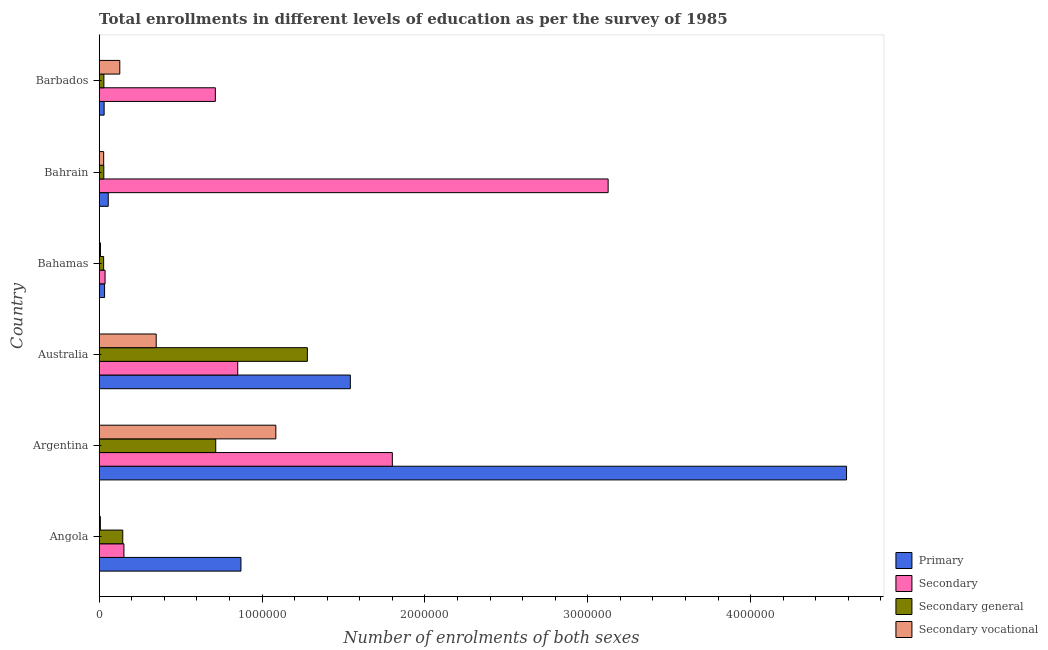How many different coloured bars are there?
Provide a short and direct response. 4. How many bars are there on the 4th tick from the top?
Keep it short and to the point. 4. In how many cases, is the number of bars for a given country not equal to the number of legend labels?
Provide a succinct answer. 0. What is the number of enrolments in secondary general education in Angola?
Your response must be concise. 1.45e+05. Across all countries, what is the maximum number of enrolments in secondary vocational education?
Offer a terse response. 1.08e+06. Across all countries, what is the minimum number of enrolments in primary education?
Ensure brevity in your answer.  3.02e+04. In which country was the number of enrolments in secondary vocational education minimum?
Provide a succinct answer. Angola. What is the total number of enrolments in secondary education in the graph?
Offer a very short reply. 6.68e+06. What is the difference between the number of enrolments in primary education in Angola and that in Bahrain?
Provide a short and direct response. 8.15e+05. What is the difference between the number of enrolments in secondary general education in Australia and the number of enrolments in secondary education in Bahamas?
Ensure brevity in your answer.  1.24e+06. What is the average number of enrolments in primary education per country?
Ensure brevity in your answer.  1.19e+06. What is the difference between the number of enrolments in secondary vocational education and number of enrolments in secondary general education in Angola?
Your answer should be very brief. -1.37e+05. What is the ratio of the number of enrolments in secondary vocational education in Bahamas to that in Barbados?
Your answer should be very brief. 0.06. What is the difference between the highest and the second highest number of enrolments in secondary vocational education?
Your answer should be very brief. 7.35e+05. What is the difference between the highest and the lowest number of enrolments in secondary vocational education?
Offer a very short reply. 1.08e+06. In how many countries, is the number of enrolments in secondary general education greater than the average number of enrolments in secondary general education taken over all countries?
Make the answer very short. 2. Is it the case that in every country, the sum of the number of enrolments in secondary education and number of enrolments in primary education is greater than the sum of number of enrolments in secondary general education and number of enrolments in secondary vocational education?
Your response must be concise. No. What does the 2nd bar from the top in Bahrain represents?
Your answer should be very brief. Secondary general. What does the 4th bar from the bottom in Angola represents?
Make the answer very short. Secondary vocational. How many countries are there in the graph?
Your response must be concise. 6. Are the values on the major ticks of X-axis written in scientific E-notation?
Give a very brief answer. No. Does the graph contain grids?
Ensure brevity in your answer.  No. Where does the legend appear in the graph?
Offer a very short reply. Bottom right. How many legend labels are there?
Your response must be concise. 4. How are the legend labels stacked?
Offer a terse response. Vertical. What is the title of the graph?
Keep it short and to the point. Total enrollments in different levels of education as per the survey of 1985. Does "Offering training" appear as one of the legend labels in the graph?
Give a very brief answer. No. What is the label or title of the X-axis?
Your response must be concise. Number of enrolments of both sexes. What is the Number of enrolments of both sexes of Primary in Angola?
Give a very brief answer. 8.70e+05. What is the Number of enrolments of both sexes of Secondary in Angola?
Your response must be concise. 1.52e+05. What is the Number of enrolments of both sexes in Secondary general in Angola?
Ensure brevity in your answer.  1.45e+05. What is the Number of enrolments of both sexes in Secondary vocational in Angola?
Offer a very short reply. 7147. What is the Number of enrolments of both sexes in Primary in Argentina?
Make the answer very short. 4.59e+06. What is the Number of enrolments of both sexes in Secondary in Argentina?
Your response must be concise. 1.80e+06. What is the Number of enrolments of both sexes of Secondary general in Argentina?
Your answer should be very brief. 7.16e+05. What is the Number of enrolments of both sexes in Secondary vocational in Argentina?
Provide a succinct answer. 1.08e+06. What is the Number of enrolments of both sexes of Primary in Australia?
Your answer should be compact. 1.54e+06. What is the Number of enrolments of both sexes of Secondary in Australia?
Ensure brevity in your answer.  8.51e+05. What is the Number of enrolments of both sexes in Secondary general in Australia?
Offer a terse response. 1.28e+06. What is the Number of enrolments of both sexes in Secondary vocational in Australia?
Your answer should be compact. 3.50e+05. What is the Number of enrolments of both sexes of Primary in Bahamas?
Provide a short and direct response. 3.29e+04. What is the Number of enrolments of both sexes of Secondary in Bahamas?
Your answer should be very brief. 3.59e+04. What is the Number of enrolments of both sexes of Secondary general in Bahamas?
Provide a short and direct response. 2.71e+04. What is the Number of enrolments of both sexes in Secondary vocational in Bahamas?
Ensure brevity in your answer.  7648. What is the Number of enrolments of both sexes in Primary in Bahrain?
Give a very brief answer. 5.55e+04. What is the Number of enrolments of both sexes of Secondary in Bahrain?
Your response must be concise. 3.13e+06. What is the Number of enrolments of both sexes in Secondary general in Bahrain?
Make the answer very short. 2.83e+04. What is the Number of enrolments of both sexes in Secondary vocational in Bahrain?
Give a very brief answer. 2.73e+04. What is the Number of enrolments of both sexes in Primary in Barbados?
Keep it short and to the point. 3.02e+04. What is the Number of enrolments of both sexes in Secondary in Barbados?
Your response must be concise. 7.13e+05. What is the Number of enrolments of both sexes in Secondary general in Barbados?
Ensure brevity in your answer.  2.87e+04. What is the Number of enrolments of both sexes in Secondary vocational in Barbados?
Keep it short and to the point. 1.26e+05. Across all countries, what is the maximum Number of enrolments of both sexes in Primary?
Offer a terse response. 4.59e+06. Across all countries, what is the maximum Number of enrolments of both sexes of Secondary?
Provide a short and direct response. 3.13e+06. Across all countries, what is the maximum Number of enrolments of both sexes of Secondary general?
Provide a succinct answer. 1.28e+06. Across all countries, what is the maximum Number of enrolments of both sexes in Secondary vocational?
Your answer should be compact. 1.08e+06. Across all countries, what is the minimum Number of enrolments of both sexes of Primary?
Offer a terse response. 3.02e+04. Across all countries, what is the minimum Number of enrolments of both sexes in Secondary?
Provide a short and direct response. 3.59e+04. Across all countries, what is the minimum Number of enrolments of both sexes in Secondary general?
Offer a very short reply. 2.71e+04. Across all countries, what is the minimum Number of enrolments of both sexes in Secondary vocational?
Your answer should be compact. 7147. What is the total Number of enrolments of both sexes of Primary in the graph?
Your response must be concise. 7.12e+06. What is the total Number of enrolments of both sexes in Secondary in the graph?
Provide a succinct answer. 6.68e+06. What is the total Number of enrolments of both sexes in Secondary general in the graph?
Offer a very short reply. 2.22e+06. What is the total Number of enrolments of both sexes of Secondary vocational in the graph?
Your answer should be very brief. 1.60e+06. What is the difference between the Number of enrolments of both sexes of Primary in Angola and that in Argentina?
Provide a succinct answer. -3.72e+06. What is the difference between the Number of enrolments of both sexes in Secondary in Angola and that in Argentina?
Your answer should be very brief. -1.65e+06. What is the difference between the Number of enrolments of both sexes in Secondary general in Angola and that in Argentina?
Your response must be concise. -5.71e+05. What is the difference between the Number of enrolments of both sexes of Secondary vocational in Angola and that in Argentina?
Ensure brevity in your answer.  -1.08e+06. What is the difference between the Number of enrolments of both sexes of Primary in Angola and that in Australia?
Provide a short and direct response. -6.72e+05. What is the difference between the Number of enrolments of both sexes of Secondary in Angola and that in Australia?
Ensure brevity in your answer.  -6.99e+05. What is the difference between the Number of enrolments of both sexes of Secondary general in Angola and that in Australia?
Keep it short and to the point. -1.13e+06. What is the difference between the Number of enrolments of both sexes of Secondary vocational in Angola and that in Australia?
Your response must be concise. -3.43e+05. What is the difference between the Number of enrolments of both sexes of Primary in Angola and that in Bahamas?
Provide a short and direct response. 8.37e+05. What is the difference between the Number of enrolments of both sexes of Secondary in Angola and that in Bahamas?
Ensure brevity in your answer.  1.16e+05. What is the difference between the Number of enrolments of both sexes of Secondary general in Angola and that in Bahamas?
Offer a very short reply. 1.17e+05. What is the difference between the Number of enrolments of both sexes of Secondary vocational in Angola and that in Bahamas?
Provide a short and direct response. -501. What is the difference between the Number of enrolments of both sexes of Primary in Angola and that in Bahrain?
Provide a short and direct response. 8.15e+05. What is the difference between the Number of enrolments of both sexes in Secondary in Angola and that in Bahrain?
Provide a short and direct response. -2.97e+06. What is the difference between the Number of enrolments of both sexes in Secondary general in Angola and that in Bahrain?
Give a very brief answer. 1.16e+05. What is the difference between the Number of enrolments of both sexes of Secondary vocational in Angola and that in Bahrain?
Make the answer very short. -2.02e+04. What is the difference between the Number of enrolments of both sexes in Primary in Angola and that in Barbados?
Offer a terse response. 8.40e+05. What is the difference between the Number of enrolments of both sexes in Secondary in Angola and that in Barbados?
Keep it short and to the point. -5.61e+05. What is the difference between the Number of enrolments of both sexes of Secondary general in Angola and that in Barbados?
Provide a short and direct response. 1.16e+05. What is the difference between the Number of enrolments of both sexes in Secondary vocational in Angola and that in Barbados?
Keep it short and to the point. -1.19e+05. What is the difference between the Number of enrolments of both sexes in Primary in Argentina and that in Australia?
Offer a terse response. 3.05e+06. What is the difference between the Number of enrolments of both sexes in Secondary in Argentina and that in Australia?
Offer a very short reply. 9.49e+05. What is the difference between the Number of enrolments of both sexes in Secondary general in Argentina and that in Australia?
Your response must be concise. -5.63e+05. What is the difference between the Number of enrolments of both sexes in Secondary vocational in Argentina and that in Australia?
Offer a very short reply. 7.35e+05. What is the difference between the Number of enrolments of both sexes of Primary in Argentina and that in Bahamas?
Provide a short and direct response. 4.56e+06. What is the difference between the Number of enrolments of both sexes of Secondary in Argentina and that in Bahamas?
Your answer should be compact. 1.76e+06. What is the difference between the Number of enrolments of both sexes in Secondary general in Argentina and that in Bahamas?
Provide a succinct answer. 6.88e+05. What is the difference between the Number of enrolments of both sexes of Secondary vocational in Argentina and that in Bahamas?
Provide a succinct answer. 1.08e+06. What is the difference between the Number of enrolments of both sexes of Primary in Argentina and that in Bahrain?
Provide a short and direct response. 4.53e+06. What is the difference between the Number of enrolments of both sexes in Secondary in Argentina and that in Bahrain?
Offer a very short reply. -1.33e+06. What is the difference between the Number of enrolments of both sexes of Secondary general in Argentina and that in Bahrain?
Give a very brief answer. 6.87e+05. What is the difference between the Number of enrolments of both sexes of Secondary vocational in Argentina and that in Bahrain?
Give a very brief answer. 1.06e+06. What is the difference between the Number of enrolments of both sexes of Primary in Argentina and that in Barbados?
Provide a succinct answer. 4.56e+06. What is the difference between the Number of enrolments of both sexes in Secondary in Argentina and that in Barbados?
Give a very brief answer. 1.09e+06. What is the difference between the Number of enrolments of both sexes in Secondary general in Argentina and that in Barbados?
Keep it short and to the point. 6.87e+05. What is the difference between the Number of enrolments of both sexes of Secondary vocational in Argentina and that in Barbados?
Your answer should be very brief. 9.58e+05. What is the difference between the Number of enrolments of both sexes in Primary in Australia and that in Bahamas?
Provide a succinct answer. 1.51e+06. What is the difference between the Number of enrolments of both sexes in Secondary in Australia and that in Bahamas?
Your response must be concise. 8.15e+05. What is the difference between the Number of enrolments of both sexes in Secondary general in Australia and that in Bahamas?
Offer a very short reply. 1.25e+06. What is the difference between the Number of enrolments of both sexes in Secondary vocational in Australia and that in Bahamas?
Your answer should be very brief. 3.42e+05. What is the difference between the Number of enrolments of both sexes in Primary in Australia and that in Bahrain?
Provide a succinct answer. 1.49e+06. What is the difference between the Number of enrolments of both sexes of Secondary in Australia and that in Bahrain?
Your answer should be very brief. -2.27e+06. What is the difference between the Number of enrolments of both sexes in Secondary general in Australia and that in Bahrain?
Offer a terse response. 1.25e+06. What is the difference between the Number of enrolments of both sexes of Secondary vocational in Australia and that in Bahrain?
Keep it short and to the point. 3.23e+05. What is the difference between the Number of enrolments of both sexes of Primary in Australia and that in Barbados?
Your answer should be compact. 1.51e+06. What is the difference between the Number of enrolments of both sexes of Secondary in Australia and that in Barbados?
Give a very brief answer. 1.38e+05. What is the difference between the Number of enrolments of both sexes in Secondary general in Australia and that in Barbados?
Offer a terse response. 1.25e+06. What is the difference between the Number of enrolments of both sexes in Secondary vocational in Australia and that in Barbados?
Offer a terse response. 2.24e+05. What is the difference between the Number of enrolments of both sexes of Primary in Bahamas and that in Bahrain?
Give a very brief answer. -2.26e+04. What is the difference between the Number of enrolments of both sexes in Secondary in Bahamas and that in Bahrain?
Offer a very short reply. -3.09e+06. What is the difference between the Number of enrolments of both sexes of Secondary general in Bahamas and that in Bahrain?
Ensure brevity in your answer.  -1106. What is the difference between the Number of enrolments of both sexes of Secondary vocational in Bahamas and that in Bahrain?
Ensure brevity in your answer.  -1.97e+04. What is the difference between the Number of enrolments of both sexes in Primary in Bahamas and that in Barbados?
Your answer should be compact. 2753. What is the difference between the Number of enrolments of both sexes of Secondary in Bahamas and that in Barbados?
Your answer should be very brief. -6.77e+05. What is the difference between the Number of enrolments of both sexes of Secondary general in Bahamas and that in Barbados?
Keep it short and to the point. -1548. What is the difference between the Number of enrolments of both sexes of Secondary vocational in Bahamas and that in Barbados?
Your answer should be compact. -1.19e+05. What is the difference between the Number of enrolments of both sexes in Primary in Bahrain and that in Barbados?
Provide a short and direct response. 2.53e+04. What is the difference between the Number of enrolments of both sexes in Secondary in Bahrain and that in Barbados?
Provide a short and direct response. 2.41e+06. What is the difference between the Number of enrolments of both sexes in Secondary general in Bahrain and that in Barbados?
Provide a short and direct response. -442. What is the difference between the Number of enrolments of both sexes of Secondary vocational in Bahrain and that in Barbados?
Provide a short and direct response. -9.91e+04. What is the difference between the Number of enrolments of both sexes in Primary in Angola and the Number of enrolments of both sexes in Secondary in Argentina?
Give a very brief answer. -9.30e+05. What is the difference between the Number of enrolments of both sexes in Primary in Angola and the Number of enrolments of both sexes in Secondary general in Argentina?
Offer a very short reply. 1.55e+05. What is the difference between the Number of enrolments of both sexes of Primary in Angola and the Number of enrolments of both sexes of Secondary vocational in Argentina?
Make the answer very short. -2.14e+05. What is the difference between the Number of enrolments of both sexes of Secondary in Angola and the Number of enrolments of both sexes of Secondary general in Argentina?
Your response must be concise. -5.64e+05. What is the difference between the Number of enrolments of both sexes of Secondary in Angola and the Number of enrolments of both sexes of Secondary vocational in Argentina?
Keep it short and to the point. -9.33e+05. What is the difference between the Number of enrolments of both sexes of Secondary general in Angola and the Number of enrolments of both sexes of Secondary vocational in Argentina?
Provide a succinct answer. -9.40e+05. What is the difference between the Number of enrolments of both sexes in Primary in Angola and the Number of enrolments of both sexes in Secondary in Australia?
Offer a terse response. 1.98e+04. What is the difference between the Number of enrolments of both sexes in Primary in Angola and the Number of enrolments of both sexes in Secondary general in Australia?
Give a very brief answer. -4.08e+05. What is the difference between the Number of enrolments of both sexes in Primary in Angola and the Number of enrolments of both sexes in Secondary vocational in Australia?
Your answer should be compact. 5.20e+05. What is the difference between the Number of enrolments of both sexes in Secondary in Angola and the Number of enrolments of both sexes in Secondary general in Australia?
Ensure brevity in your answer.  -1.13e+06. What is the difference between the Number of enrolments of both sexes in Secondary in Angola and the Number of enrolments of both sexes in Secondary vocational in Australia?
Provide a succinct answer. -1.98e+05. What is the difference between the Number of enrolments of both sexes of Secondary general in Angola and the Number of enrolments of both sexes of Secondary vocational in Australia?
Keep it short and to the point. -2.05e+05. What is the difference between the Number of enrolments of both sexes of Primary in Angola and the Number of enrolments of both sexes of Secondary in Bahamas?
Your answer should be very brief. 8.35e+05. What is the difference between the Number of enrolments of both sexes of Primary in Angola and the Number of enrolments of both sexes of Secondary general in Bahamas?
Your response must be concise. 8.43e+05. What is the difference between the Number of enrolments of both sexes of Primary in Angola and the Number of enrolments of both sexes of Secondary vocational in Bahamas?
Your answer should be compact. 8.63e+05. What is the difference between the Number of enrolments of both sexes of Secondary in Angola and the Number of enrolments of both sexes of Secondary general in Bahamas?
Provide a succinct answer. 1.25e+05. What is the difference between the Number of enrolments of both sexes in Secondary in Angola and the Number of enrolments of both sexes in Secondary vocational in Bahamas?
Offer a terse response. 1.44e+05. What is the difference between the Number of enrolments of both sexes of Secondary general in Angola and the Number of enrolments of both sexes of Secondary vocational in Bahamas?
Make the answer very short. 1.37e+05. What is the difference between the Number of enrolments of both sexes in Primary in Angola and the Number of enrolments of both sexes in Secondary in Bahrain?
Your response must be concise. -2.25e+06. What is the difference between the Number of enrolments of both sexes in Primary in Angola and the Number of enrolments of both sexes in Secondary general in Bahrain?
Offer a very short reply. 8.42e+05. What is the difference between the Number of enrolments of both sexes in Primary in Angola and the Number of enrolments of both sexes in Secondary vocational in Bahrain?
Provide a short and direct response. 8.43e+05. What is the difference between the Number of enrolments of both sexes of Secondary in Angola and the Number of enrolments of both sexes of Secondary general in Bahrain?
Make the answer very short. 1.24e+05. What is the difference between the Number of enrolments of both sexes in Secondary in Angola and the Number of enrolments of both sexes in Secondary vocational in Bahrain?
Your answer should be very brief. 1.24e+05. What is the difference between the Number of enrolments of both sexes of Secondary general in Angola and the Number of enrolments of both sexes of Secondary vocational in Bahrain?
Give a very brief answer. 1.17e+05. What is the difference between the Number of enrolments of both sexes in Primary in Angola and the Number of enrolments of both sexes in Secondary in Barbados?
Give a very brief answer. 1.57e+05. What is the difference between the Number of enrolments of both sexes of Primary in Angola and the Number of enrolments of both sexes of Secondary general in Barbados?
Your answer should be compact. 8.42e+05. What is the difference between the Number of enrolments of both sexes in Primary in Angola and the Number of enrolments of both sexes in Secondary vocational in Barbados?
Your response must be concise. 7.44e+05. What is the difference between the Number of enrolments of both sexes in Secondary in Angola and the Number of enrolments of both sexes in Secondary general in Barbados?
Make the answer very short. 1.23e+05. What is the difference between the Number of enrolments of both sexes in Secondary in Angola and the Number of enrolments of both sexes in Secondary vocational in Barbados?
Your response must be concise. 2.54e+04. What is the difference between the Number of enrolments of both sexes of Secondary general in Angola and the Number of enrolments of both sexes of Secondary vocational in Barbados?
Provide a short and direct response. 1.82e+04. What is the difference between the Number of enrolments of both sexes of Primary in Argentina and the Number of enrolments of both sexes of Secondary in Australia?
Provide a short and direct response. 3.74e+06. What is the difference between the Number of enrolments of both sexes in Primary in Argentina and the Number of enrolments of both sexes in Secondary general in Australia?
Your response must be concise. 3.31e+06. What is the difference between the Number of enrolments of both sexes of Primary in Argentina and the Number of enrolments of both sexes of Secondary vocational in Australia?
Provide a succinct answer. 4.24e+06. What is the difference between the Number of enrolments of both sexes of Secondary in Argentina and the Number of enrolments of both sexes of Secondary general in Australia?
Keep it short and to the point. 5.22e+05. What is the difference between the Number of enrolments of both sexes of Secondary in Argentina and the Number of enrolments of both sexes of Secondary vocational in Australia?
Ensure brevity in your answer.  1.45e+06. What is the difference between the Number of enrolments of both sexes in Secondary general in Argentina and the Number of enrolments of both sexes in Secondary vocational in Australia?
Your answer should be very brief. 3.66e+05. What is the difference between the Number of enrolments of both sexes of Primary in Argentina and the Number of enrolments of both sexes of Secondary in Bahamas?
Provide a short and direct response. 4.55e+06. What is the difference between the Number of enrolments of both sexes of Primary in Argentina and the Number of enrolments of both sexes of Secondary general in Bahamas?
Offer a terse response. 4.56e+06. What is the difference between the Number of enrolments of both sexes of Primary in Argentina and the Number of enrolments of both sexes of Secondary vocational in Bahamas?
Your answer should be compact. 4.58e+06. What is the difference between the Number of enrolments of both sexes of Secondary in Argentina and the Number of enrolments of both sexes of Secondary general in Bahamas?
Provide a short and direct response. 1.77e+06. What is the difference between the Number of enrolments of both sexes of Secondary in Argentina and the Number of enrolments of both sexes of Secondary vocational in Bahamas?
Offer a terse response. 1.79e+06. What is the difference between the Number of enrolments of both sexes of Secondary general in Argentina and the Number of enrolments of both sexes of Secondary vocational in Bahamas?
Give a very brief answer. 7.08e+05. What is the difference between the Number of enrolments of both sexes in Primary in Argentina and the Number of enrolments of both sexes in Secondary in Bahrain?
Your answer should be compact. 1.46e+06. What is the difference between the Number of enrolments of both sexes of Primary in Argentina and the Number of enrolments of both sexes of Secondary general in Bahrain?
Offer a very short reply. 4.56e+06. What is the difference between the Number of enrolments of both sexes in Primary in Argentina and the Number of enrolments of both sexes in Secondary vocational in Bahrain?
Your answer should be very brief. 4.56e+06. What is the difference between the Number of enrolments of both sexes in Secondary in Argentina and the Number of enrolments of both sexes in Secondary general in Bahrain?
Keep it short and to the point. 1.77e+06. What is the difference between the Number of enrolments of both sexes in Secondary in Argentina and the Number of enrolments of both sexes in Secondary vocational in Bahrain?
Your answer should be very brief. 1.77e+06. What is the difference between the Number of enrolments of both sexes of Secondary general in Argentina and the Number of enrolments of both sexes of Secondary vocational in Bahrain?
Give a very brief answer. 6.88e+05. What is the difference between the Number of enrolments of both sexes in Primary in Argentina and the Number of enrolments of both sexes in Secondary in Barbados?
Your answer should be very brief. 3.88e+06. What is the difference between the Number of enrolments of both sexes in Primary in Argentina and the Number of enrolments of both sexes in Secondary general in Barbados?
Your answer should be very brief. 4.56e+06. What is the difference between the Number of enrolments of both sexes in Primary in Argentina and the Number of enrolments of both sexes in Secondary vocational in Barbados?
Give a very brief answer. 4.46e+06. What is the difference between the Number of enrolments of both sexes in Secondary in Argentina and the Number of enrolments of both sexes in Secondary general in Barbados?
Offer a terse response. 1.77e+06. What is the difference between the Number of enrolments of both sexes of Secondary in Argentina and the Number of enrolments of both sexes of Secondary vocational in Barbados?
Ensure brevity in your answer.  1.67e+06. What is the difference between the Number of enrolments of both sexes in Secondary general in Argentina and the Number of enrolments of both sexes in Secondary vocational in Barbados?
Your answer should be compact. 5.89e+05. What is the difference between the Number of enrolments of both sexes in Primary in Australia and the Number of enrolments of both sexes in Secondary in Bahamas?
Ensure brevity in your answer.  1.51e+06. What is the difference between the Number of enrolments of both sexes in Primary in Australia and the Number of enrolments of both sexes in Secondary general in Bahamas?
Your response must be concise. 1.51e+06. What is the difference between the Number of enrolments of both sexes in Primary in Australia and the Number of enrolments of both sexes in Secondary vocational in Bahamas?
Your answer should be very brief. 1.53e+06. What is the difference between the Number of enrolments of both sexes of Secondary in Australia and the Number of enrolments of both sexes of Secondary general in Bahamas?
Make the answer very short. 8.24e+05. What is the difference between the Number of enrolments of both sexes in Secondary in Australia and the Number of enrolments of both sexes in Secondary vocational in Bahamas?
Ensure brevity in your answer.  8.43e+05. What is the difference between the Number of enrolments of both sexes in Secondary general in Australia and the Number of enrolments of both sexes in Secondary vocational in Bahamas?
Provide a short and direct response. 1.27e+06. What is the difference between the Number of enrolments of both sexes in Primary in Australia and the Number of enrolments of both sexes in Secondary in Bahrain?
Provide a succinct answer. -1.58e+06. What is the difference between the Number of enrolments of both sexes in Primary in Australia and the Number of enrolments of both sexes in Secondary general in Bahrain?
Ensure brevity in your answer.  1.51e+06. What is the difference between the Number of enrolments of both sexes of Primary in Australia and the Number of enrolments of both sexes of Secondary vocational in Bahrain?
Give a very brief answer. 1.51e+06. What is the difference between the Number of enrolments of both sexes of Secondary in Australia and the Number of enrolments of both sexes of Secondary general in Bahrain?
Offer a very short reply. 8.22e+05. What is the difference between the Number of enrolments of both sexes of Secondary in Australia and the Number of enrolments of both sexes of Secondary vocational in Bahrain?
Keep it short and to the point. 8.23e+05. What is the difference between the Number of enrolments of both sexes of Secondary general in Australia and the Number of enrolments of both sexes of Secondary vocational in Bahrain?
Keep it short and to the point. 1.25e+06. What is the difference between the Number of enrolments of both sexes of Primary in Australia and the Number of enrolments of both sexes of Secondary in Barbados?
Give a very brief answer. 8.29e+05. What is the difference between the Number of enrolments of both sexes in Primary in Australia and the Number of enrolments of both sexes in Secondary general in Barbados?
Provide a short and direct response. 1.51e+06. What is the difference between the Number of enrolments of both sexes of Primary in Australia and the Number of enrolments of both sexes of Secondary vocational in Barbados?
Your answer should be compact. 1.42e+06. What is the difference between the Number of enrolments of both sexes of Secondary in Australia and the Number of enrolments of both sexes of Secondary general in Barbados?
Give a very brief answer. 8.22e+05. What is the difference between the Number of enrolments of both sexes of Secondary in Australia and the Number of enrolments of both sexes of Secondary vocational in Barbados?
Your answer should be very brief. 7.24e+05. What is the difference between the Number of enrolments of both sexes of Secondary general in Australia and the Number of enrolments of both sexes of Secondary vocational in Barbados?
Give a very brief answer. 1.15e+06. What is the difference between the Number of enrolments of both sexes of Primary in Bahamas and the Number of enrolments of both sexes of Secondary in Bahrain?
Provide a short and direct response. -3.09e+06. What is the difference between the Number of enrolments of both sexes of Primary in Bahamas and the Number of enrolments of both sexes of Secondary general in Bahrain?
Offer a terse response. 4661. What is the difference between the Number of enrolments of both sexes in Primary in Bahamas and the Number of enrolments of both sexes in Secondary vocational in Bahrain?
Make the answer very short. 5566. What is the difference between the Number of enrolments of both sexes of Secondary in Bahamas and the Number of enrolments of both sexes of Secondary general in Bahrain?
Offer a very short reply. 7648. What is the difference between the Number of enrolments of both sexes of Secondary in Bahamas and the Number of enrolments of both sexes of Secondary vocational in Bahrain?
Your response must be concise. 8553. What is the difference between the Number of enrolments of both sexes of Secondary general in Bahamas and the Number of enrolments of both sexes of Secondary vocational in Bahrain?
Your answer should be very brief. -201. What is the difference between the Number of enrolments of both sexes in Primary in Bahamas and the Number of enrolments of both sexes in Secondary in Barbados?
Make the answer very short. -6.80e+05. What is the difference between the Number of enrolments of both sexes in Primary in Bahamas and the Number of enrolments of both sexes in Secondary general in Barbados?
Your answer should be compact. 4219. What is the difference between the Number of enrolments of both sexes in Primary in Bahamas and the Number of enrolments of both sexes in Secondary vocational in Barbados?
Make the answer very short. -9.35e+04. What is the difference between the Number of enrolments of both sexes in Secondary in Bahamas and the Number of enrolments of both sexes in Secondary general in Barbados?
Provide a succinct answer. 7206. What is the difference between the Number of enrolments of both sexes in Secondary in Bahamas and the Number of enrolments of both sexes in Secondary vocational in Barbados?
Your answer should be compact. -9.05e+04. What is the difference between the Number of enrolments of both sexes in Secondary general in Bahamas and the Number of enrolments of both sexes in Secondary vocational in Barbados?
Offer a terse response. -9.93e+04. What is the difference between the Number of enrolments of both sexes of Primary in Bahrain and the Number of enrolments of both sexes of Secondary in Barbados?
Your answer should be very brief. -6.58e+05. What is the difference between the Number of enrolments of both sexes in Primary in Bahrain and the Number of enrolments of both sexes in Secondary general in Barbados?
Your response must be concise. 2.68e+04. What is the difference between the Number of enrolments of both sexes in Primary in Bahrain and the Number of enrolments of both sexes in Secondary vocational in Barbados?
Your answer should be very brief. -7.09e+04. What is the difference between the Number of enrolments of both sexes of Secondary in Bahrain and the Number of enrolments of both sexes of Secondary general in Barbados?
Offer a terse response. 3.10e+06. What is the difference between the Number of enrolments of both sexes in Secondary in Bahrain and the Number of enrolments of both sexes in Secondary vocational in Barbados?
Keep it short and to the point. 3.00e+06. What is the difference between the Number of enrolments of both sexes in Secondary general in Bahrain and the Number of enrolments of both sexes in Secondary vocational in Barbados?
Offer a very short reply. -9.81e+04. What is the average Number of enrolments of both sexes in Primary per country?
Make the answer very short. 1.19e+06. What is the average Number of enrolments of both sexes in Secondary per country?
Provide a short and direct response. 1.11e+06. What is the average Number of enrolments of both sexes in Secondary general per country?
Your answer should be very brief. 3.70e+05. What is the average Number of enrolments of both sexes of Secondary vocational per country?
Give a very brief answer. 2.67e+05. What is the difference between the Number of enrolments of both sexes of Primary and Number of enrolments of both sexes of Secondary in Angola?
Offer a very short reply. 7.19e+05. What is the difference between the Number of enrolments of both sexes in Primary and Number of enrolments of both sexes in Secondary general in Angola?
Offer a very short reply. 7.26e+05. What is the difference between the Number of enrolments of both sexes of Primary and Number of enrolments of both sexes of Secondary vocational in Angola?
Provide a short and direct response. 8.63e+05. What is the difference between the Number of enrolments of both sexes of Secondary and Number of enrolments of both sexes of Secondary general in Angola?
Give a very brief answer. 7147. What is the difference between the Number of enrolments of both sexes in Secondary and Number of enrolments of both sexes in Secondary vocational in Angola?
Ensure brevity in your answer.  1.45e+05. What is the difference between the Number of enrolments of both sexes in Secondary general and Number of enrolments of both sexes in Secondary vocational in Angola?
Your answer should be very brief. 1.37e+05. What is the difference between the Number of enrolments of both sexes in Primary and Number of enrolments of both sexes in Secondary in Argentina?
Provide a succinct answer. 2.79e+06. What is the difference between the Number of enrolments of both sexes in Primary and Number of enrolments of both sexes in Secondary general in Argentina?
Provide a short and direct response. 3.87e+06. What is the difference between the Number of enrolments of both sexes of Primary and Number of enrolments of both sexes of Secondary vocational in Argentina?
Your answer should be very brief. 3.50e+06. What is the difference between the Number of enrolments of both sexes in Secondary and Number of enrolments of both sexes in Secondary general in Argentina?
Your answer should be very brief. 1.08e+06. What is the difference between the Number of enrolments of both sexes of Secondary and Number of enrolments of both sexes of Secondary vocational in Argentina?
Your answer should be compact. 7.16e+05. What is the difference between the Number of enrolments of both sexes of Secondary general and Number of enrolments of both sexes of Secondary vocational in Argentina?
Your answer should be compact. -3.69e+05. What is the difference between the Number of enrolments of both sexes of Primary and Number of enrolments of both sexes of Secondary in Australia?
Your response must be concise. 6.91e+05. What is the difference between the Number of enrolments of both sexes of Primary and Number of enrolments of both sexes of Secondary general in Australia?
Make the answer very short. 2.64e+05. What is the difference between the Number of enrolments of both sexes of Primary and Number of enrolments of both sexes of Secondary vocational in Australia?
Your response must be concise. 1.19e+06. What is the difference between the Number of enrolments of both sexes of Secondary and Number of enrolments of both sexes of Secondary general in Australia?
Your answer should be compact. -4.28e+05. What is the difference between the Number of enrolments of both sexes of Secondary and Number of enrolments of both sexes of Secondary vocational in Australia?
Make the answer very short. 5.01e+05. What is the difference between the Number of enrolments of both sexes of Secondary general and Number of enrolments of both sexes of Secondary vocational in Australia?
Provide a short and direct response. 9.28e+05. What is the difference between the Number of enrolments of both sexes of Primary and Number of enrolments of both sexes of Secondary in Bahamas?
Your answer should be very brief. -2987. What is the difference between the Number of enrolments of both sexes in Primary and Number of enrolments of both sexes in Secondary general in Bahamas?
Ensure brevity in your answer.  5767. What is the difference between the Number of enrolments of both sexes of Primary and Number of enrolments of both sexes of Secondary vocational in Bahamas?
Keep it short and to the point. 2.53e+04. What is the difference between the Number of enrolments of both sexes of Secondary and Number of enrolments of both sexes of Secondary general in Bahamas?
Offer a very short reply. 8754. What is the difference between the Number of enrolments of both sexes of Secondary and Number of enrolments of both sexes of Secondary vocational in Bahamas?
Your answer should be compact. 2.83e+04. What is the difference between the Number of enrolments of both sexes in Secondary general and Number of enrolments of both sexes in Secondary vocational in Bahamas?
Ensure brevity in your answer.  1.95e+04. What is the difference between the Number of enrolments of both sexes of Primary and Number of enrolments of both sexes of Secondary in Bahrain?
Provide a succinct answer. -3.07e+06. What is the difference between the Number of enrolments of both sexes of Primary and Number of enrolments of both sexes of Secondary general in Bahrain?
Your answer should be very brief. 2.72e+04. What is the difference between the Number of enrolments of both sexes in Primary and Number of enrolments of both sexes in Secondary vocational in Bahrain?
Provide a succinct answer. 2.81e+04. What is the difference between the Number of enrolments of both sexes of Secondary and Number of enrolments of both sexes of Secondary general in Bahrain?
Keep it short and to the point. 3.10e+06. What is the difference between the Number of enrolments of both sexes in Secondary and Number of enrolments of both sexes in Secondary vocational in Bahrain?
Offer a very short reply. 3.10e+06. What is the difference between the Number of enrolments of both sexes in Secondary general and Number of enrolments of both sexes in Secondary vocational in Bahrain?
Make the answer very short. 905. What is the difference between the Number of enrolments of both sexes in Primary and Number of enrolments of both sexes in Secondary in Barbados?
Give a very brief answer. -6.83e+05. What is the difference between the Number of enrolments of both sexes of Primary and Number of enrolments of both sexes of Secondary general in Barbados?
Your answer should be very brief. 1466. What is the difference between the Number of enrolments of both sexes of Primary and Number of enrolments of both sexes of Secondary vocational in Barbados?
Keep it short and to the point. -9.62e+04. What is the difference between the Number of enrolments of both sexes of Secondary and Number of enrolments of both sexes of Secondary general in Barbados?
Your answer should be very brief. 6.84e+05. What is the difference between the Number of enrolments of both sexes in Secondary and Number of enrolments of both sexes in Secondary vocational in Barbados?
Provide a succinct answer. 5.87e+05. What is the difference between the Number of enrolments of both sexes in Secondary general and Number of enrolments of both sexes in Secondary vocational in Barbados?
Make the answer very short. -9.77e+04. What is the ratio of the Number of enrolments of both sexes of Primary in Angola to that in Argentina?
Provide a succinct answer. 0.19. What is the ratio of the Number of enrolments of both sexes in Secondary in Angola to that in Argentina?
Keep it short and to the point. 0.08. What is the ratio of the Number of enrolments of both sexes of Secondary general in Angola to that in Argentina?
Your answer should be very brief. 0.2. What is the ratio of the Number of enrolments of both sexes of Secondary vocational in Angola to that in Argentina?
Provide a succinct answer. 0.01. What is the ratio of the Number of enrolments of both sexes of Primary in Angola to that in Australia?
Offer a very short reply. 0.56. What is the ratio of the Number of enrolments of both sexes in Secondary in Angola to that in Australia?
Your response must be concise. 0.18. What is the ratio of the Number of enrolments of both sexes in Secondary general in Angola to that in Australia?
Provide a succinct answer. 0.11. What is the ratio of the Number of enrolments of both sexes in Secondary vocational in Angola to that in Australia?
Make the answer very short. 0.02. What is the ratio of the Number of enrolments of both sexes of Primary in Angola to that in Bahamas?
Your response must be concise. 26.45. What is the ratio of the Number of enrolments of both sexes in Secondary in Angola to that in Bahamas?
Your response must be concise. 4.23. What is the ratio of the Number of enrolments of both sexes of Secondary general in Angola to that in Bahamas?
Offer a terse response. 5.33. What is the ratio of the Number of enrolments of both sexes in Secondary vocational in Angola to that in Bahamas?
Your answer should be very brief. 0.93. What is the ratio of the Number of enrolments of both sexes in Primary in Angola to that in Bahrain?
Give a very brief answer. 15.68. What is the ratio of the Number of enrolments of both sexes in Secondary in Angola to that in Bahrain?
Make the answer very short. 0.05. What is the ratio of the Number of enrolments of both sexes in Secondary general in Angola to that in Bahrain?
Offer a terse response. 5.12. What is the ratio of the Number of enrolments of both sexes of Secondary vocational in Angola to that in Bahrain?
Ensure brevity in your answer.  0.26. What is the ratio of the Number of enrolments of both sexes in Primary in Angola to that in Barbados?
Provide a succinct answer. 28.86. What is the ratio of the Number of enrolments of both sexes of Secondary in Angola to that in Barbados?
Your response must be concise. 0.21. What is the ratio of the Number of enrolments of both sexes of Secondary general in Angola to that in Barbados?
Ensure brevity in your answer.  5.04. What is the ratio of the Number of enrolments of both sexes in Secondary vocational in Angola to that in Barbados?
Provide a short and direct response. 0.06. What is the ratio of the Number of enrolments of both sexes of Primary in Argentina to that in Australia?
Your response must be concise. 2.98. What is the ratio of the Number of enrolments of both sexes of Secondary in Argentina to that in Australia?
Offer a very short reply. 2.12. What is the ratio of the Number of enrolments of both sexes in Secondary general in Argentina to that in Australia?
Your answer should be very brief. 0.56. What is the ratio of the Number of enrolments of both sexes of Secondary vocational in Argentina to that in Australia?
Give a very brief answer. 3.1. What is the ratio of the Number of enrolments of both sexes of Primary in Argentina to that in Bahamas?
Give a very brief answer. 139.43. What is the ratio of the Number of enrolments of both sexes of Secondary in Argentina to that in Bahamas?
Ensure brevity in your answer.  50.14. What is the ratio of the Number of enrolments of both sexes in Secondary general in Argentina to that in Bahamas?
Your answer should be compact. 26.36. What is the ratio of the Number of enrolments of both sexes in Secondary vocational in Argentina to that in Bahamas?
Your answer should be compact. 141.81. What is the ratio of the Number of enrolments of both sexes of Primary in Argentina to that in Bahrain?
Offer a terse response. 82.7. What is the ratio of the Number of enrolments of both sexes of Secondary in Argentina to that in Bahrain?
Provide a short and direct response. 0.58. What is the ratio of the Number of enrolments of both sexes of Secondary general in Argentina to that in Bahrain?
Provide a succinct answer. 25.33. What is the ratio of the Number of enrolments of both sexes of Secondary vocational in Argentina to that in Bahrain?
Offer a terse response. 39.66. What is the ratio of the Number of enrolments of both sexes of Primary in Argentina to that in Barbados?
Offer a very short reply. 152.16. What is the ratio of the Number of enrolments of both sexes of Secondary in Argentina to that in Barbados?
Make the answer very short. 2.52. What is the ratio of the Number of enrolments of both sexes in Secondary general in Argentina to that in Barbados?
Ensure brevity in your answer.  24.94. What is the ratio of the Number of enrolments of both sexes in Secondary vocational in Argentina to that in Barbados?
Your response must be concise. 8.58. What is the ratio of the Number of enrolments of both sexes in Primary in Australia to that in Bahamas?
Your response must be concise. 46.85. What is the ratio of the Number of enrolments of both sexes in Secondary in Australia to that in Bahamas?
Ensure brevity in your answer.  23.69. What is the ratio of the Number of enrolments of both sexes in Secondary general in Australia to that in Bahamas?
Your answer should be compact. 47.09. What is the ratio of the Number of enrolments of both sexes in Secondary vocational in Australia to that in Bahamas?
Give a very brief answer. 45.76. What is the ratio of the Number of enrolments of both sexes in Primary in Australia to that in Bahrain?
Your answer should be very brief. 27.79. What is the ratio of the Number of enrolments of both sexes in Secondary in Australia to that in Bahrain?
Your answer should be very brief. 0.27. What is the ratio of the Number of enrolments of both sexes of Secondary general in Australia to that in Bahrain?
Your answer should be compact. 45.24. What is the ratio of the Number of enrolments of both sexes in Secondary vocational in Australia to that in Bahrain?
Make the answer very short. 12.8. What is the ratio of the Number of enrolments of both sexes in Primary in Australia to that in Barbados?
Offer a very short reply. 51.13. What is the ratio of the Number of enrolments of both sexes in Secondary in Australia to that in Barbados?
Ensure brevity in your answer.  1.19. What is the ratio of the Number of enrolments of both sexes of Secondary general in Australia to that in Barbados?
Offer a terse response. 44.55. What is the ratio of the Number of enrolments of both sexes of Secondary vocational in Australia to that in Barbados?
Offer a very short reply. 2.77. What is the ratio of the Number of enrolments of both sexes in Primary in Bahamas to that in Bahrain?
Ensure brevity in your answer.  0.59. What is the ratio of the Number of enrolments of both sexes in Secondary in Bahamas to that in Bahrain?
Offer a terse response. 0.01. What is the ratio of the Number of enrolments of both sexes of Secondary general in Bahamas to that in Bahrain?
Provide a short and direct response. 0.96. What is the ratio of the Number of enrolments of both sexes in Secondary vocational in Bahamas to that in Bahrain?
Give a very brief answer. 0.28. What is the ratio of the Number of enrolments of both sexes in Primary in Bahamas to that in Barbados?
Ensure brevity in your answer.  1.09. What is the ratio of the Number of enrolments of both sexes of Secondary in Bahamas to that in Barbados?
Your response must be concise. 0.05. What is the ratio of the Number of enrolments of both sexes in Secondary general in Bahamas to that in Barbados?
Your answer should be very brief. 0.95. What is the ratio of the Number of enrolments of both sexes in Secondary vocational in Bahamas to that in Barbados?
Keep it short and to the point. 0.06. What is the ratio of the Number of enrolments of both sexes of Primary in Bahrain to that in Barbados?
Your response must be concise. 1.84. What is the ratio of the Number of enrolments of both sexes in Secondary in Bahrain to that in Barbados?
Give a very brief answer. 4.38. What is the ratio of the Number of enrolments of both sexes of Secondary general in Bahrain to that in Barbados?
Ensure brevity in your answer.  0.98. What is the ratio of the Number of enrolments of both sexes of Secondary vocational in Bahrain to that in Barbados?
Offer a terse response. 0.22. What is the difference between the highest and the second highest Number of enrolments of both sexes of Primary?
Your response must be concise. 3.05e+06. What is the difference between the highest and the second highest Number of enrolments of both sexes of Secondary?
Provide a short and direct response. 1.33e+06. What is the difference between the highest and the second highest Number of enrolments of both sexes of Secondary general?
Keep it short and to the point. 5.63e+05. What is the difference between the highest and the second highest Number of enrolments of both sexes in Secondary vocational?
Offer a terse response. 7.35e+05. What is the difference between the highest and the lowest Number of enrolments of both sexes in Primary?
Give a very brief answer. 4.56e+06. What is the difference between the highest and the lowest Number of enrolments of both sexes of Secondary?
Offer a terse response. 3.09e+06. What is the difference between the highest and the lowest Number of enrolments of both sexes in Secondary general?
Your answer should be very brief. 1.25e+06. What is the difference between the highest and the lowest Number of enrolments of both sexes in Secondary vocational?
Provide a succinct answer. 1.08e+06. 